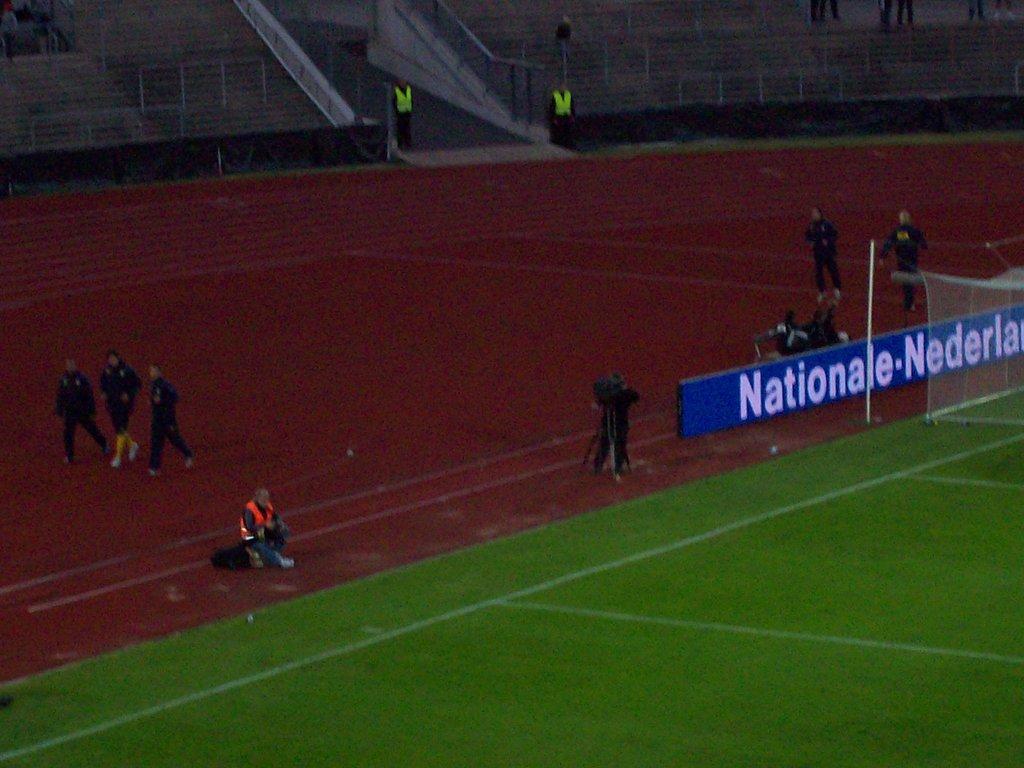What country is mentioned in this picture?
Keep it short and to the point. Nederlands. What company has sponsored this event?
Make the answer very short. Nationale. 